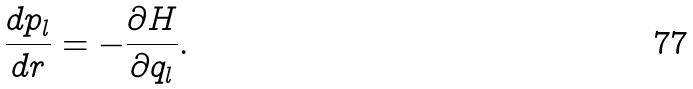<formula> <loc_0><loc_0><loc_500><loc_500>\frac { d p _ { l } } { d r } = - \frac { \partial H } { \partial q _ { l } } .</formula> 